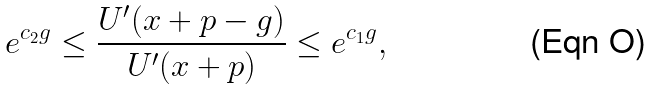<formula> <loc_0><loc_0><loc_500><loc_500>e ^ { c _ { 2 } g } \leq \frac { U ^ { \prime } ( x + p - g ) } { U ^ { \prime } ( x + p ) } \leq e ^ { c _ { 1 } g } ,</formula> 